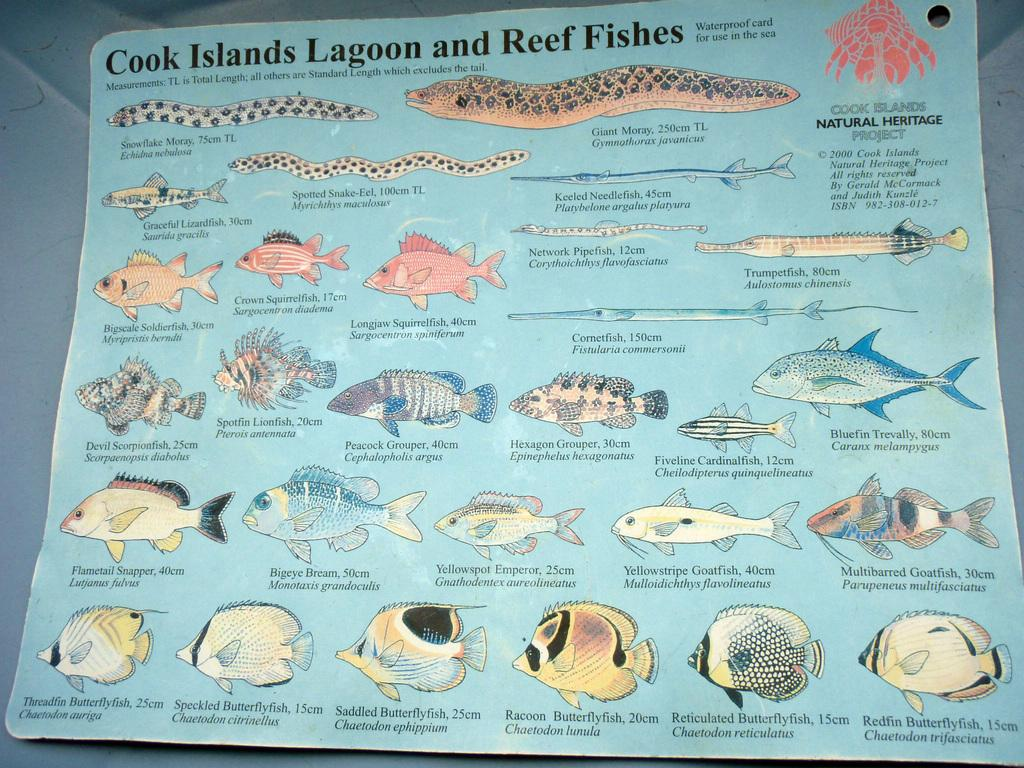What is featured on the poster in the image? The poster contains images of fish. What else can be found on the poster besides the images of fish? There is text on the poster. How many flowers are depicted on the poster? There are no flowers present on the poster; it features images of fish and text. 